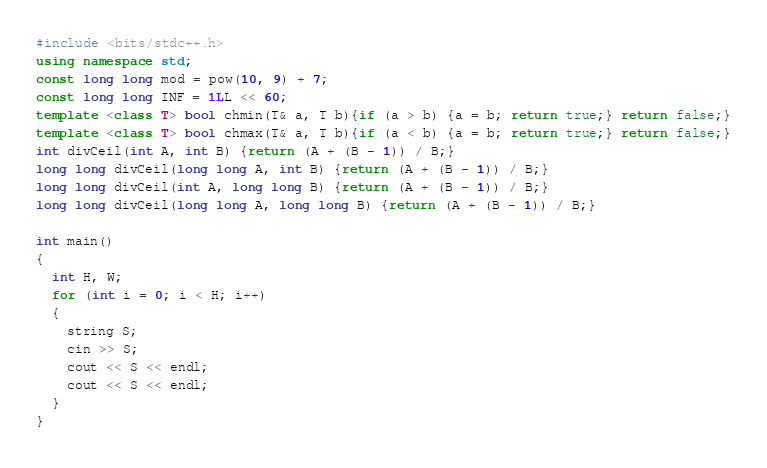Convert code to text. <code><loc_0><loc_0><loc_500><loc_500><_C++_>#include <bits/stdc++.h>
using namespace std;
const long long mod = pow(10, 9) + 7;
const long long INF = 1LL << 60;
template <class T> bool chmin(T& a, T b){if (a > b) {a = b; return true;} return false;}
template <class T> bool chmax(T& a, T b){if (a < b) {a = b; return true;} return false;}
int divCeil(int A, int B) {return (A + (B - 1)) / B;}
long long divCeil(long long A, int B) {return (A + (B - 1)) / B;}
long long divCeil(int A, long long B) {return (A + (B - 1)) / B;}
long long divCeil(long long A, long long B) {return (A + (B - 1)) / B;}

int main()
{
  int H, W;
  for (int i = 0; i < H; i++)
  {
    string S;
    cin >> S;
    cout << S << endl;
    cout << S << endl;
  }
}</code> 